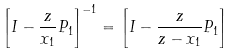<formula> <loc_0><loc_0><loc_500><loc_500>\left [ I - \frac { z } { x _ { 1 } } P _ { 1 } \right ] ^ { - 1 } = \left [ I - \frac { z } { z - x _ { 1 } } P _ { 1 } \right ]</formula> 